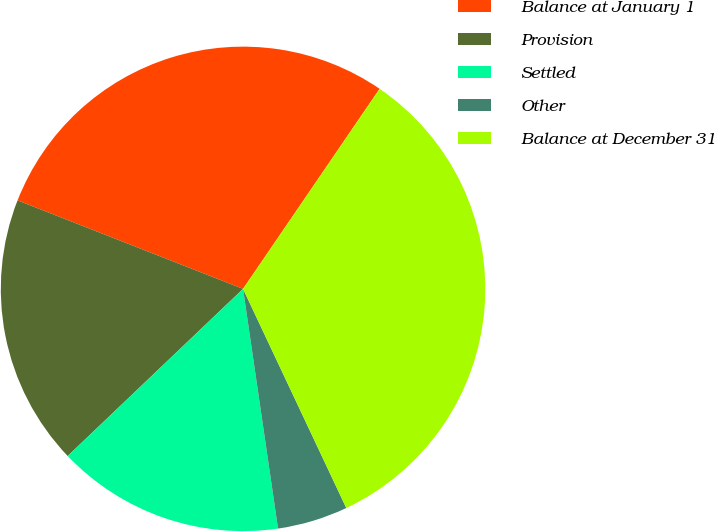Convert chart. <chart><loc_0><loc_0><loc_500><loc_500><pie_chart><fcel>Balance at January 1<fcel>Provision<fcel>Settled<fcel>Other<fcel>Balance at December 31<nl><fcel>28.58%<fcel>18.07%<fcel>15.19%<fcel>4.7%<fcel>33.46%<nl></chart> 